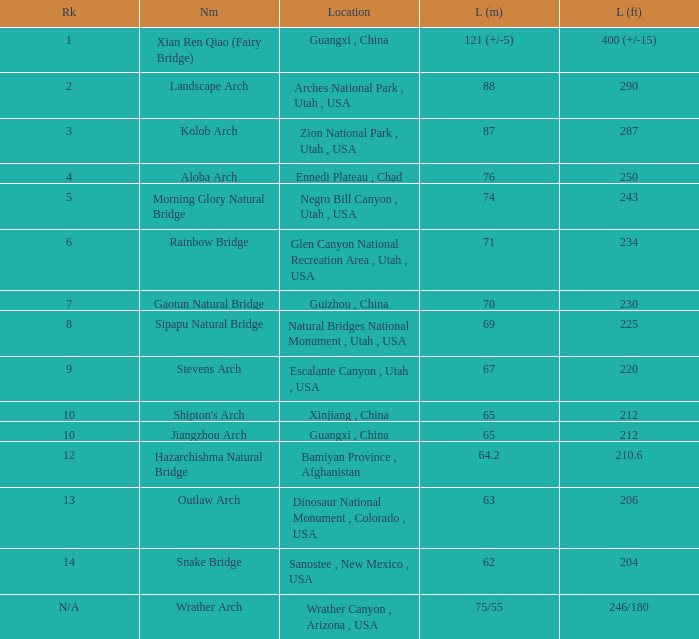What place does an arch with a length of 75/55 meters hold in the ranking? N/A. 